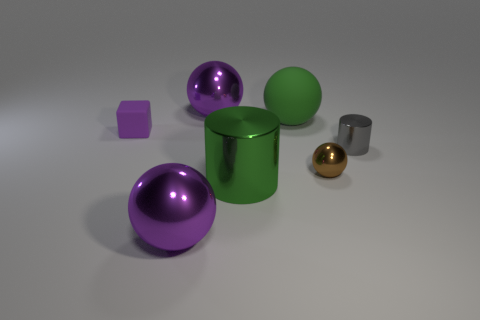What material is the big thing that is the same color as the large cylinder?
Make the answer very short. Rubber. Does the tiny cube have the same color as the large metal sphere behind the tiny matte block?
Make the answer very short. Yes. What size is the brown metal object that is the same shape as the big green matte thing?
Offer a very short reply. Small. The large metallic object that is both on the left side of the large shiny cylinder and in front of the brown shiny object has what shape?
Offer a terse response. Sphere. Is the size of the rubber block the same as the ball in front of the green cylinder?
Give a very brief answer. No. There is another small object that is the same shape as the green matte thing; what is its color?
Your response must be concise. Brown. There is a matte object that is to the right of the green cylinder; is its size the same as the purple shiny thing that is behind the small brown ball?
Keep it short and to the point. Yes. Is the tiny gray metal object the same shape as the green metal thing?
Provide a short and direct response. Yes. How many objects are either large things that are in front of the small purple object or small gray metal cylinders?
Your response must be concise. 3. Are there any other small purple things of the same shape as the small rubber object?
Make the answer very short. No. 